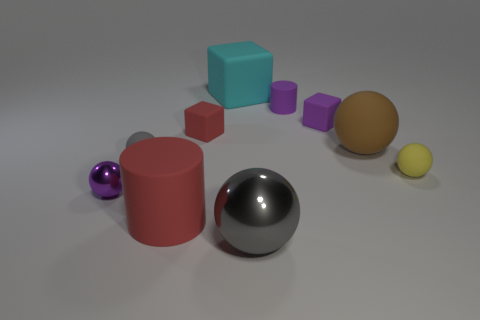Subtract all yellow cylinders. How many yellow blocks are left? 0 Subtract all small yellow shiny objects. Subtract all red matte blocks. How many objects are left? 9 Add 6 gray matte balls. How many gray matte balls are left? 7 Add 7 purple cylinders. How many purple cylinders exist? 8 Subtract all purple cubes. How many cubes are left? 2 Subtract all rubber balls. How many balls are left? 2 Subtract 1 cyan blocks. How many objects are left? 9 Subtract all cylinders. How many objects are left? 8 Subtract 2 blocks. How many blocks are left? 1 Subtract all purple balls. Subtract all gray cylinders. How many balls are left? 4 